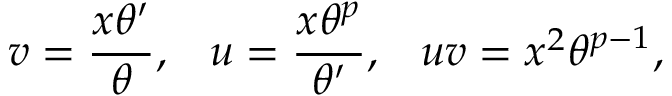<formula> <loc_0><loc_0><loc_500><loc_500>v = \frac { x \theta ^ { \prime } } { \theta } , \, u = \frac { x \theta ^ { p } } { \theta ^ { \prime } } , \, u v = x ^ { 2 } \theta ^ { p - 1 } ,</formula> 